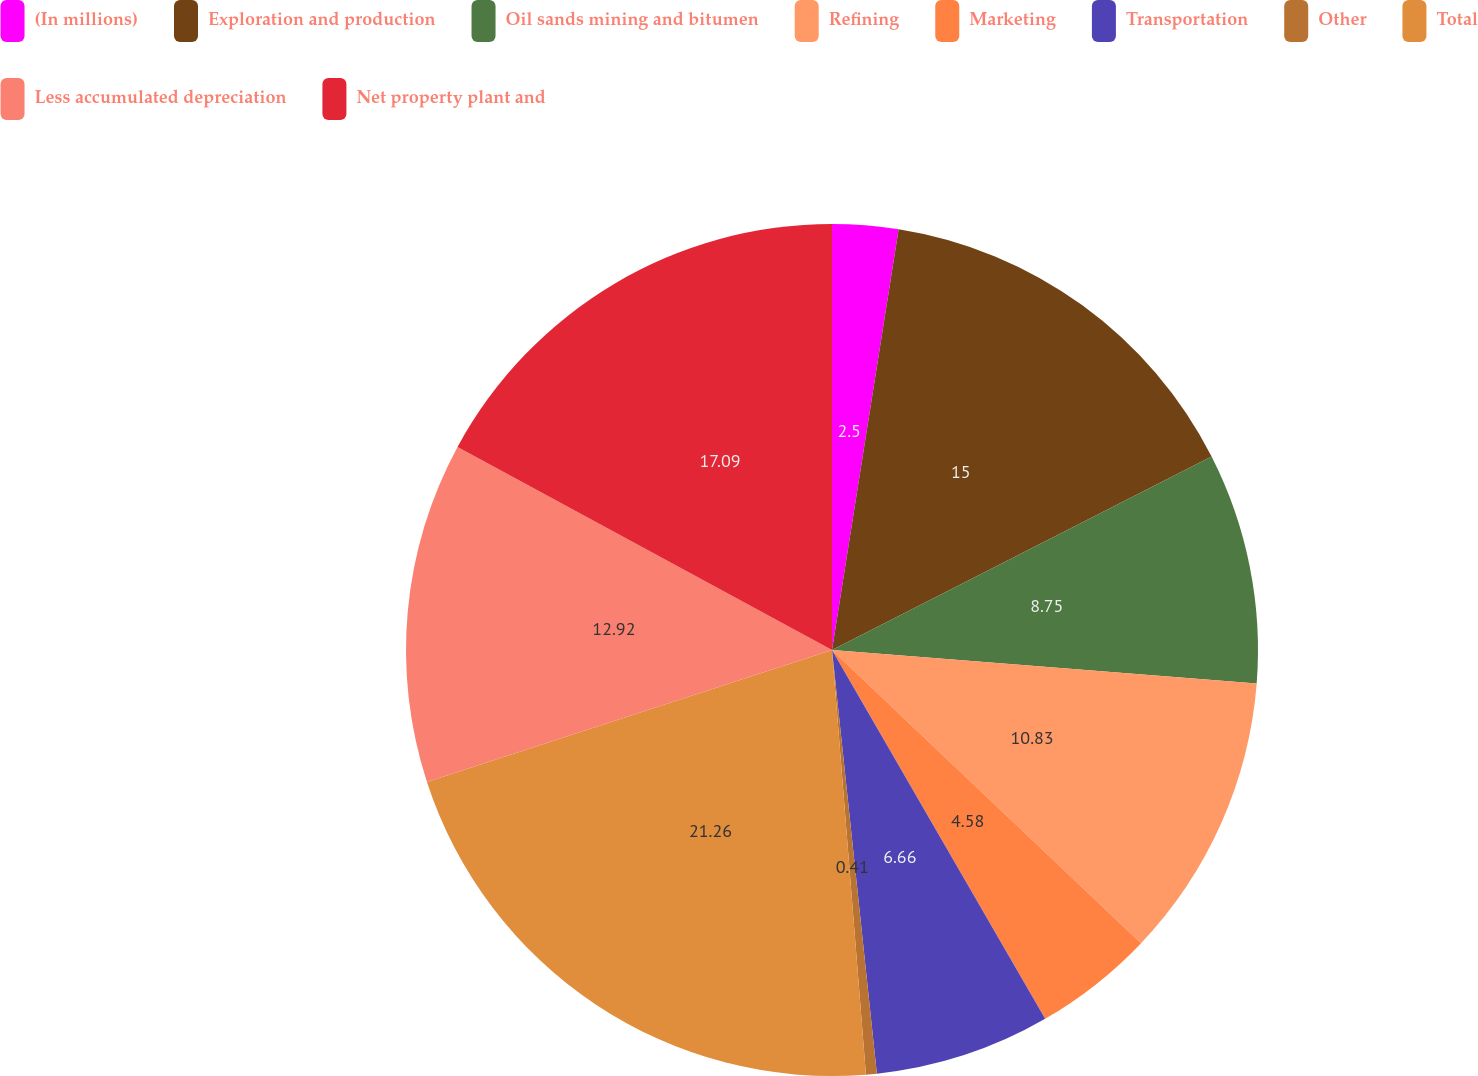Convert chart to OTSL. <chart><loc_0><loc_0><loc_500><loc_500><pie_chart><fcel>(In millions)<fcel>Exploration and production<fcel>Oil sands mining and bitumen<fcel>Refining<fcel>Marketing<fcel>Transportation<fcel>Other<fcel>Total<fcel>Less accumulated depreciation<fcel>Net property plant and<nl><fcel>2.5%<fcel>15.0%<fcel>8.75%<fcel>10.83%<fcel>4.58%<fcel>6.66%<fcel>0.41%<fcel>21.26%<fcel>12.92%<fcel>17.09%<nl></chart> 